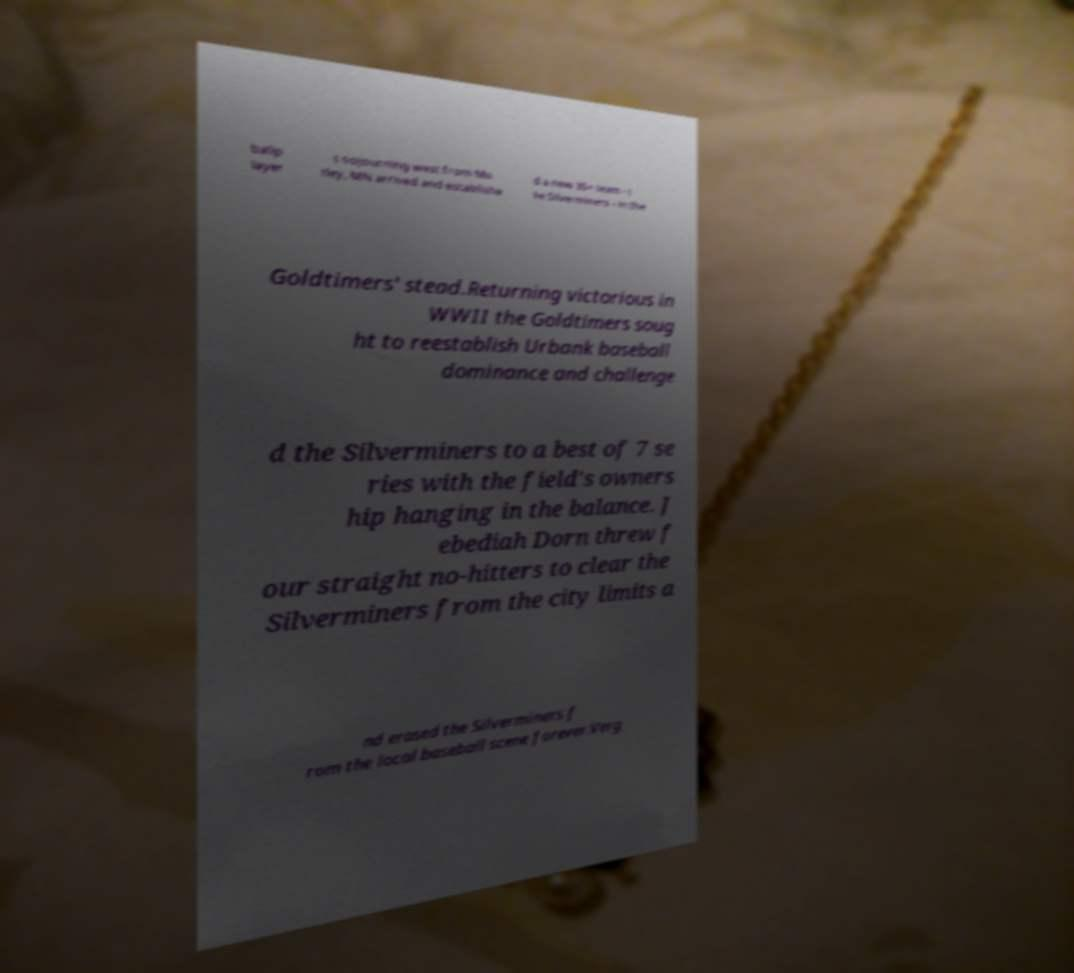There's text embedded in this image that I need extracted. Can you transcribe it verbatim? ballp layer s sojourning west from Mo tley, MN arrived and establishe d a new 35+ team - t he Silverminers - in the Goldtimers' stead.Returning victorious in WWII the Goldtimers soug ht to reestablish Urbank baseball dominance and challenge d the Silverminers to a best of 7 se ries with the field's owners hip hanging in the balance. J ebediah Dorn threw f our straight no-hitters to clear the Silverminers from the city limits a nd erased the Silverminers f rom the local baseball scene forever.Verg 